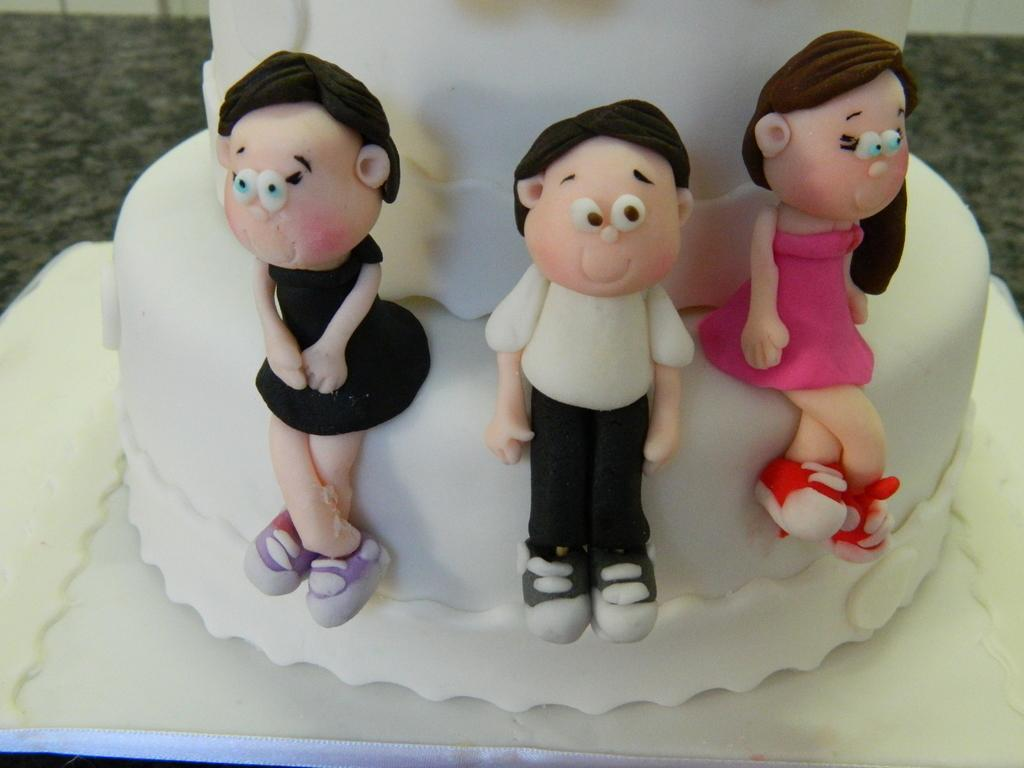How many toys can be seen in the image? There are three toys in the image. What is the toys' placement in the image? The toys are placed on a white cake. What is the color of the surface the cake is on? The cake is kept on a white surface. What can be observed about the background of the image? The background of the image is blurred. What type of celery is used as a decoration on the cake in the image? There is no celery present in the image; the toys are placed on a white cake. What level of difficulty is the cake designed for in the image? The image does not provide information about the difficulty level of the cake. 